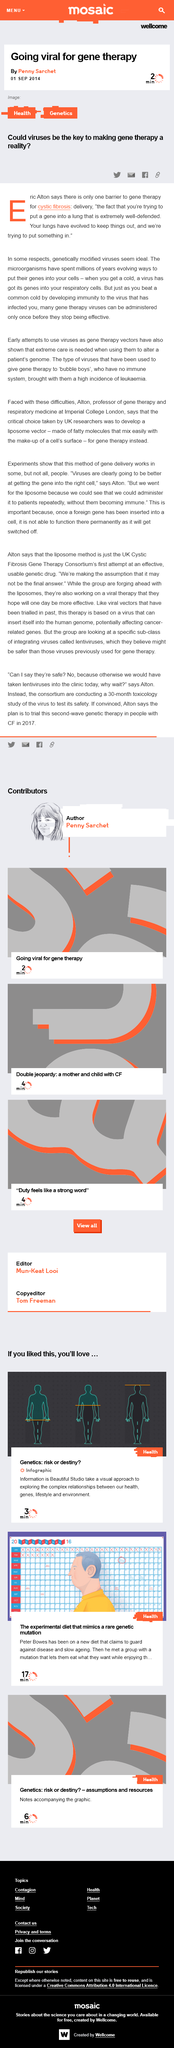Point out several critical features in this image. The article implies that viruses may serve the purpose of helping to introduce genes into the lungs. As of 2014, therapeutic genes were not in place to be inserted into the lungs of cystic fibrosis patients, as methods for such insertion had not yet been established in 2013. 